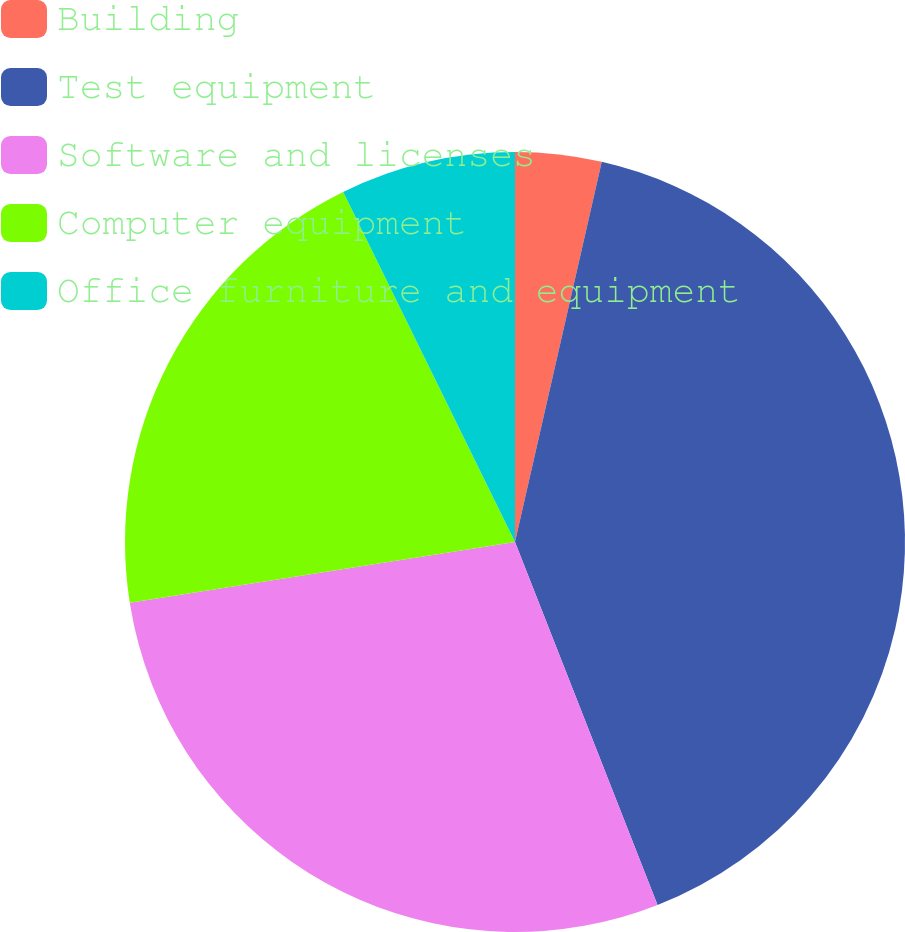Convert chart. <chart><loc_0><loc_0><loc_500><loc_500><pie_chart><fcel>Building<fcel>Test equipment<fcel>Software and licenses<fcel>Computer equipment<fcel>Office furniture and equipment<nl><fcel>3.57%<fcel>40.47%<fcel>28.46%<fcel>20.23%<fcel>7.26%<nl></chart> 